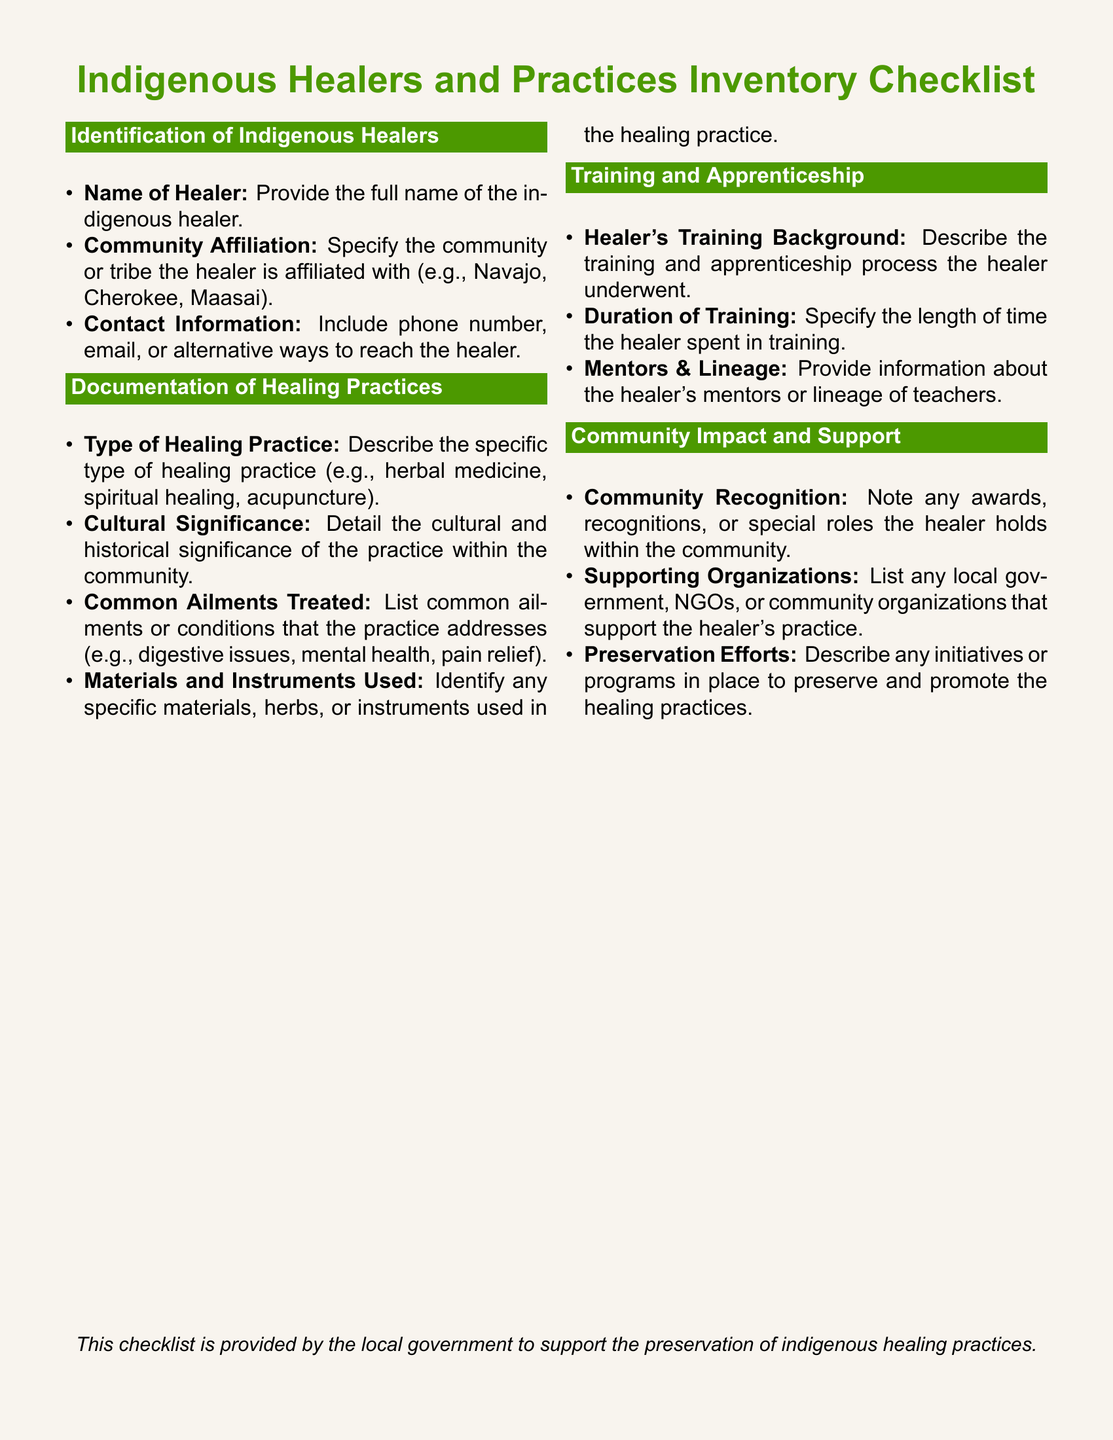What is the title of the checklist? The title of the checklist is presented at the top of the document in a prominent format.
Answer: Indigenous Healers and Practices Inventory Checklist What section details the healer's training background? The section that includes information about the healer's training background is focused on training and apprenticeship.
Answer: Training and Apprenticeship What type of information is requested under 'Community Affiliation'? The document specifically asks for the community or tribe the healer is affiliated with under this item.
Answer: Community or tribe Name one category listed under 'Documentation of Healing Practices'. The document includes categories that pertain to healing practices, one of which is the 'Type of Healing Practice'.
Answer: Type of Healing Practice How many items are listed under 'Community Impact and Support'? This section contains three specific checklist items.
Answer: Three What is a detail requested about the type of healing practice? The checklist inquires about the cultural significance associated with the type of healing practice.
Answer: Cultural significance What does the checklist indicate is the purpose of its provision? The purpose of the checklist is stated clearly at the bottom of the document.
Answer: Support the preservation of indigenous healing practices Which color is used for the section title backgrounds? The section titles use a distinct color to increase visibility and differentiation.
Answer: Earth green Who is the target audience for the checklist? The document is primarily aimed at local government officials and the community regarding indigenous healing practices.
Answer: Local government and community 